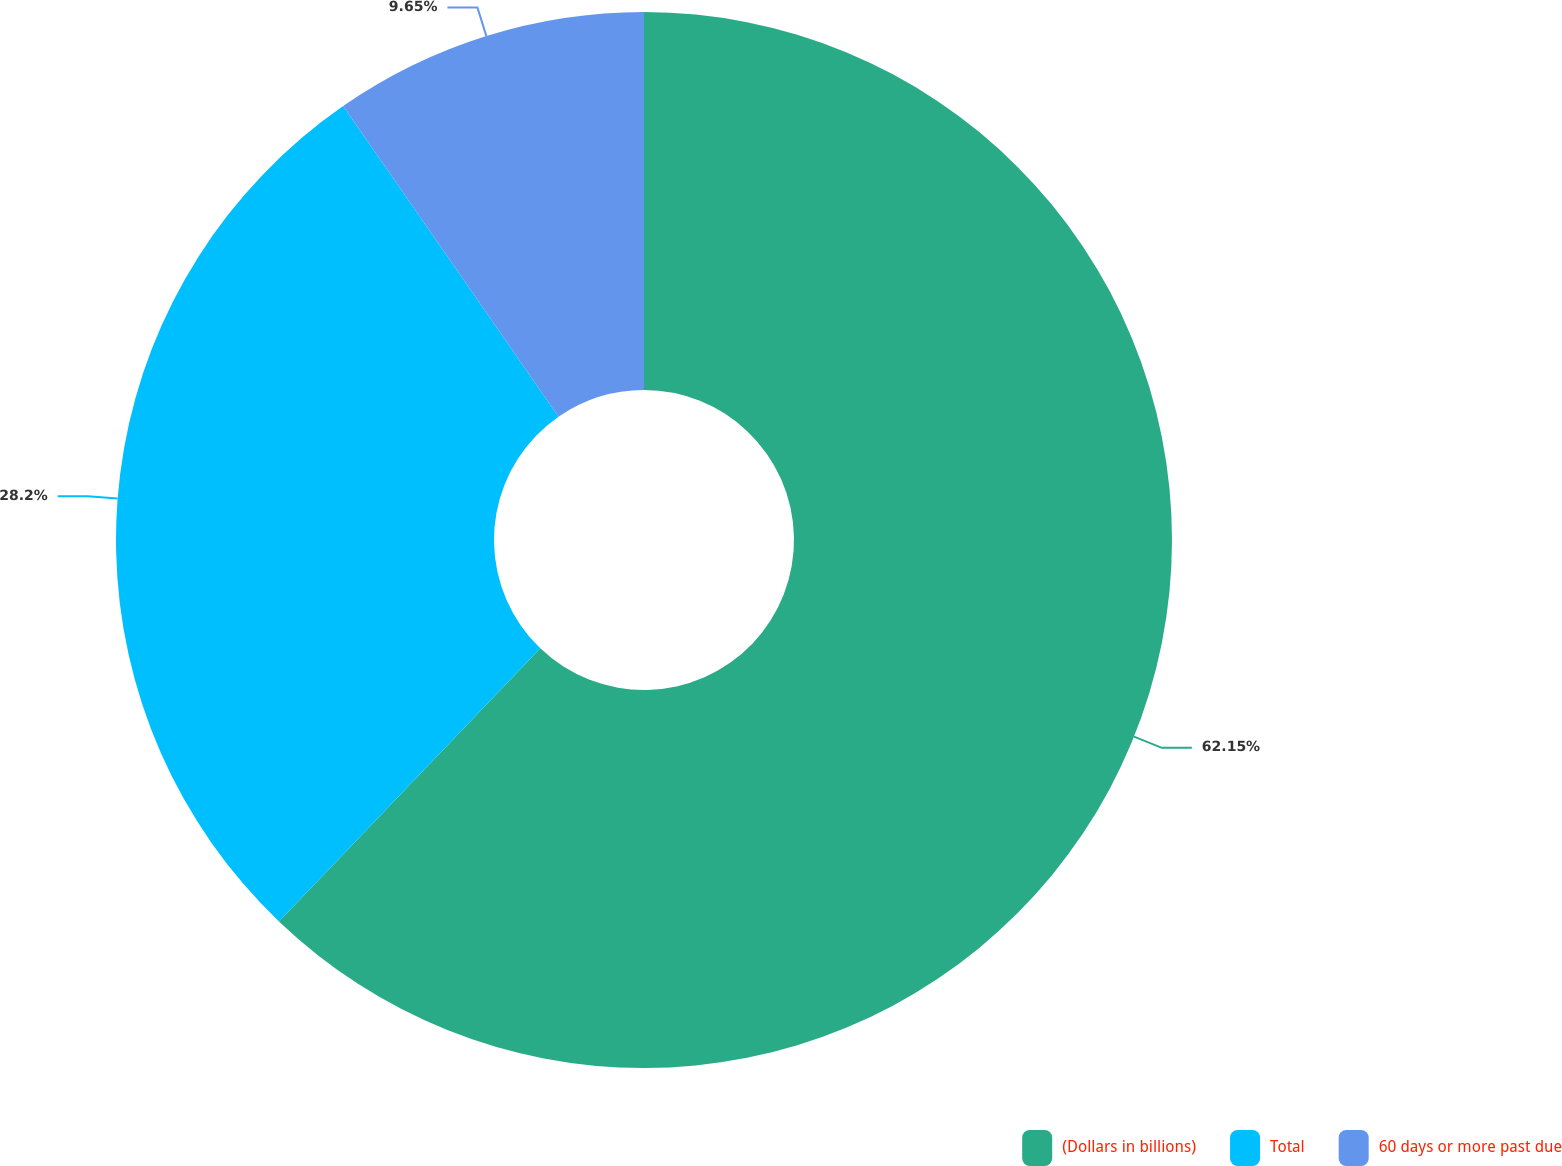<chart> <loc_0><loc_0><loc_500><loc_500><pie_chart><fcel>(Dollars in billions)<fcel>Total<fcel>60 days or more past due<nl><fcel>62.15%<fcel>28.2%<fcel>9.65%<nl></chart> 